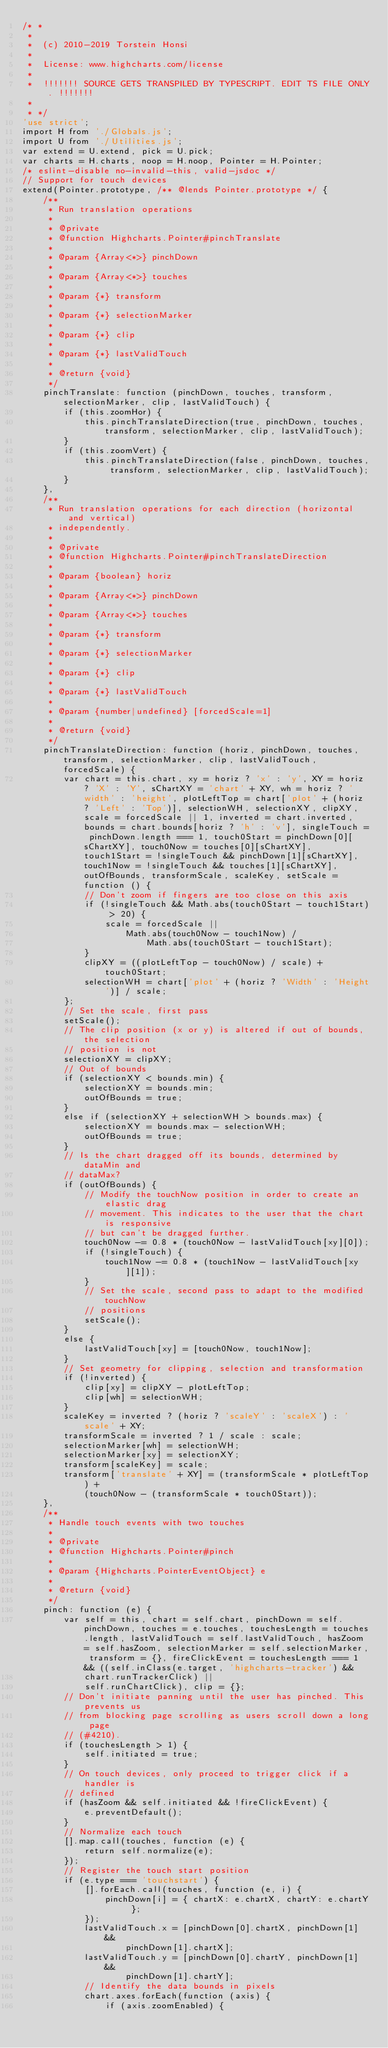<code> <loc_0><loc_0><loc_500><loc_500><_JavaScript_>/* *
 *
 *  (c) 2010-2019 Torstein Honsi
 *
 *  License: www.highcharts.com/license
 *
 *  !!!!!!! SOURCE GETS TRANSPILED BY TYPESCRIPT. EDIT TS FILE ONLY. !!!!!!!
 *
 * */
'use strict';
import H from './Globals.js';
import U from './Utilities.js';
var extend = U.extend, pick = U.pick;
var charts = H.charts, noop = H.noop, Pointer = H.Pointer;
/* eslint-disable no-invalid-this, valid-jsdoc */
// Support for touch devices
extend(Pointer.prototype, /** @lends Pointer.prototype */ {
    /**
     * Run translation operations
     *
     * @private
     * @function Highcharts.Pointer#pinchTranslate
     *
     * @param {Array<*>} pinchDown
     *
     * @param {Array<*>} touches
     *
     * @param {*} transform
     *
     * @param {*} selectionMarker
     *
     * @param {*} clip
     *
     * @param {*} lastValidTouch
     *
     * @return {void}
     */
    pinchTranslate: function (pinchDown, touches, transform, selectionMarker, clip, lastValidTouch) {
        if (this.zoomHor) {
            this.pinchTranslateDirection(true, pinchDown, touches, transform, selectionMarker, clip, lastValidTouch);
        }
        if (this.zoomVert) {
            this.pinchTranslateDirection(false, pinchDown, touches, transform, selectionMarker, clip, lastValidTouch);
        }
    },
    /**
     * Run translation operations for each direction (horizontal and vertical)
     * independently.
     *
     * @private
     * @function Highcharts.Pointer#pinchTranslateDirection
     *
     * @param {boolean} horiz
     *
     * @param {Array<*>} pinchDown
     *
     * @param {Array<*>} touches
     *
     * @param {*} transform
     *
     * @param {*} selectionMarker
     *
     * @param {*} clip
     *
     * @param {*} lastValidTouch
     *
     * @param {number|undefined} [forcedScale=1]
     *
     * @return {void}
     */
    pinchTranslateDirection: function (horiz, pinchDown, touches, transform, selectionMarker, clip, lastValidTouch, forcedScale) {
        var chart = this.chart, xy = horiz ? 'x' : 'y', XY = horiz ? 'X' : 'Y', sChartXY = 'chart' + XY, wh = horiz ? 'width' : 'height', plotLeftTop = chart['plot' + (horiz ? 'Left' : 'Top')], selectionWH, selectionXY, clipXY, scale = forcedScale || 1, inverted = chart.inverted, bounds = chart.bounds[horiz ? 'h' : 'v'], singleTouch = pinchDown.length === 1, touch0Start = pinchDown[0][sChartXY], touch0Now = touches[0][sChartXY], touch1Start = !singleTouch && pinchDown[1][sChartXY], touch1Now = !singleTouch && touches[1][sChartXY], outOfBounds, transformScale, scaleKey, setScale = function () {
            // Don't zoom if fingers are too close on this axis
            if (!singleTouch && Math.abs(touch0Start - touch1Start) > 20) {
                scale = forcedScale ||
                    Math.abs(touch0Now - touch1Now) /
                        Math.abs(touch0Start - touch1Start);
            }
            clipXY = ((plotLeftTop - touch0Now) / scale) + touch0Start;
            selectionWH = chart['plot' + (horiz ? 'Width' : 'Height')] / scale;
        };
        // Set the scale, first pass
        setScale();
        // The clip position (x or y) is altered if out of bounds, the selection
        // position is not
        selectionXY = clipXY;
        // Out of bounds
        if (selectionXY < bounds.min) {
            selectionXY = bounds.min;
            outOfBounds = true;
        }
        else if (selectionXY + selectionWH > bounds.max) {
            selectionXY = bounds.max - selectionWH;
            outOfBounds = true;
        }
        // Is the chart dragged off its bounds, determined by dataMin and
        // dataMax?
        if (outOfBounds) {
            // Modify the touchNow position in order to create an elastic drag
            // movement. This indicates to the user that the chart is responsive
            // but can't be dragged further.
            touch0Now -= 0.8 * (touch0Now - lastValidTouch[xy][0]);
            if (!singleTouch) {
                touch1Now -= 0.8 * (touch1Now - lastValidTouch[xy][1]);
            }
            // Set the scale, second pass to adapt to the modified touchNow
            // positions
            setScale();
        }
        else {
            lastValidTouch[xy] = [touch0Now, touch1Now];
        }
        // Set geometry for clipping, selection and transformation
        if (!inverted) {
            clip[xy] = clipXY - plotLeftTop;
            clip[wh] = selectionWH;
        }
        scaleKey = inverted ? (horiz ? 'scaleY' : 'scaleX') : 'scale' + XY;
        transformScale = inverted ? 1 / scale : scale;
        selectionMarker[wh] = selectionWH;
        selectionMarker[xy] = selectionXY;
        transform[scaleKey] = scale;
        transform['translate' + XY] = (transformScale * plotLeftTop) +
            (touch0Now - (transformScale * touch0Start));
    },
    /**
     * Handle touch events with two touches
     *
     * @private
     * @function Highcharts.Pointer#pinch
     *
     * @param {Highcharts.PointerEventObject} e
     *
     * @return {void}
     */
    pinch: function (e) {
        var self = this, chart = self.chart, pinchDown = self.pinchDown, touches = e.touches, touchesLength = touches.length, lastValidTouch = self.lastValidTouch, hasZoom = self.hasZoom, selectionMarker = self.selectionMarker, transform = {}, fireClickEvent = touchesLength === 1 && ((self.inClass(e.target, 'highcharts-tracker') &&
            chart.runTrackerClick) ||
            self.runChartClick), clip = {};
        // Don't initiate panning until the user has pinched. This prevents us
        // from blocking page scrolling as users scroll down a long page
        // (#4210).
        if (touchesLength > 1) {
            self.initiated = true;
        }
        // On touch devices, only proceed to trigger click if a handler is
        // defined
        if (hasZoom && self.initiated && !fireClickEvent) {
            e.preventDefault();
        }
        // Normalize each touch
        [].map.call(touches, function (e) {
            return self.normalize(e);
        });
        // Register the touch start position
        if (e.type === 'touchstart') {
            [].forEach.call(touches, function (e, i) {
                pinchDown[i] = { chartX: e.chartX, chartY: e.chartY };
            });
            lastValidTouch.x = [pinchDown[0].chartX, pinchDown[1] &&
                    pinchDown[1].chartX];
            lastValidTouch.y = [pinchDown[0].chartY, pinchDown[1] &&
                    pinchDown[1].chartY];
            // Identify the data bounds in pixels
            chart.axes.forEach(function (axis) {
                if (axis.zoomEnabled) {</code> 